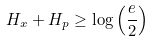<formula> <loc_0><loc_0><loc_500><loc_500>H _ { x } + H _ { p } \geq \log \left ( { \frac { e } { 2 } } \right )</formula> 